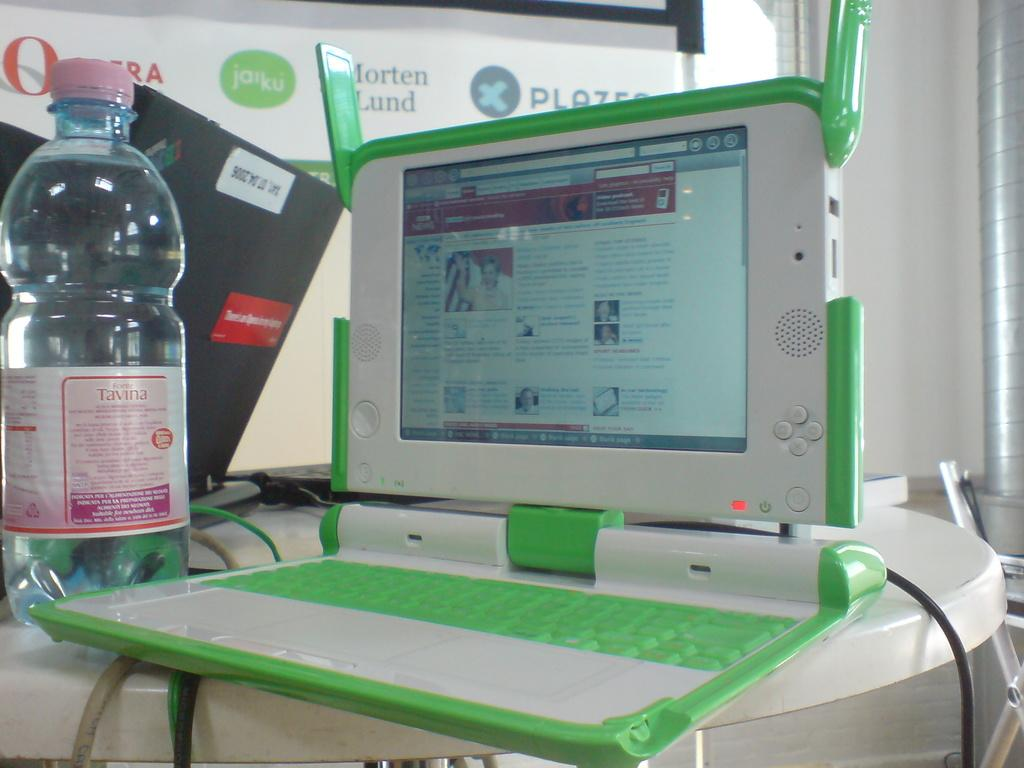<image>
Create a compact narrative representing the image presented. A plastic bottle of Tavina next to a laptop. 